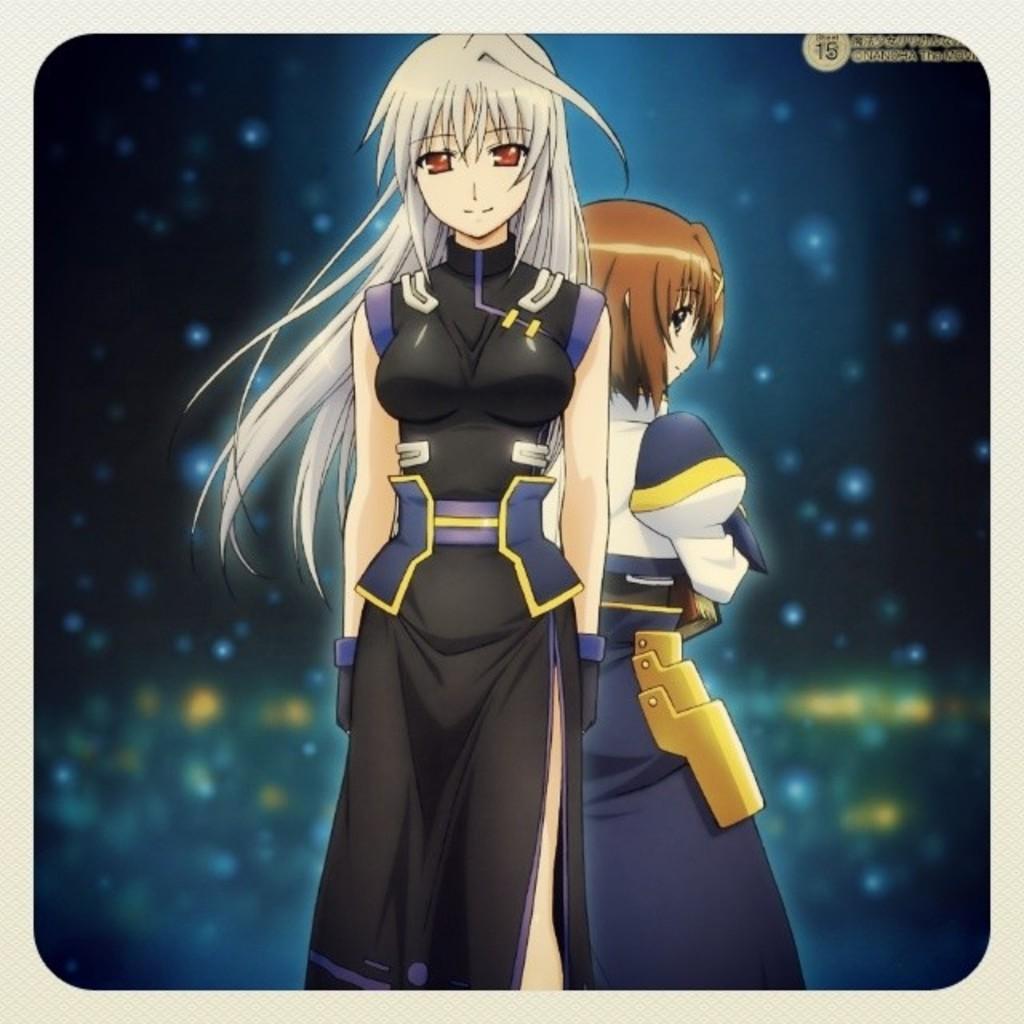Please provide a concise description of this image. In this picture there are two cartoons of a woman. One of the cartoon is wearing black dress and another is wearing blue. 